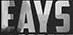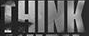Read the text from these images in sequence, separated by a semicolon. EAYS; THINK 